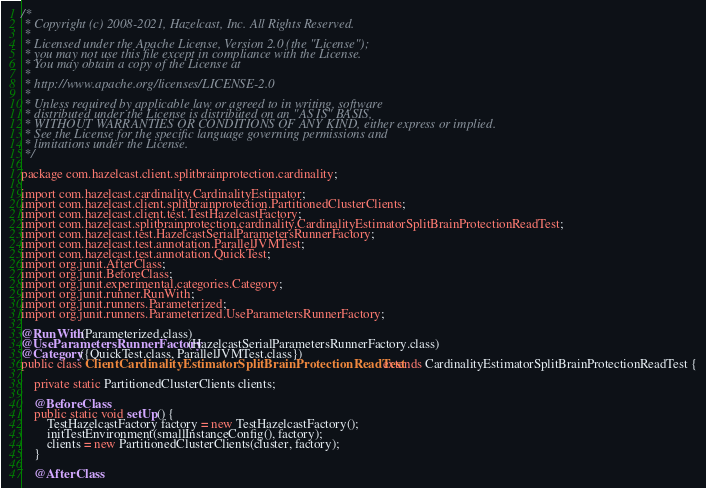<code> <loc_0><loc_0><loc_500><loc_500><_Java_>/*
 * Copyright (c) 2008-2021, Hazelcast, Inc. All Rights Reserved.
 *
 * Licensed under the Apache License, Version 2.0 (the "License");
 * you may not use this file except in compliance with the License.
 * You may obtain a copy of the License at
 *
 * http://www.apache.org/licenses/LICENSE-2.0
 *
 * Unless required by applicable law or agreed to in writing, software
 * distributed under the License is distributed on an "AS IS" BASIS,
 * WITHOUT WARRANTIES OR CONDITIONS OF ANY KIND, either express or implied.
 * See the License for the specific language governing permissions and
 * limitations under the License.
 */

package com.hazelcast.client.splitbrainprotection.cardinality;

import com.hazelcast.cardinality.CardinalityEstimator;
import com.hazelcast.client.splitbrainprotection.PartitionedClusterClients;
import com.hazelcast.client.test.TestHazelcastFactory;
import com.hazelcast.splitbrainprotection.cardinality.CardinalityEstimatorSplitBrainProtectionReadTest;
import com.hazelcast.test.HazelcastSerialParametersRunnerFactory;
import com.hazelcast.test.annotation.ParallelJVMTest;
import com.hazelcast.test.annotation.QuickTest;
import org.junit.AfterClass;
import org.junit.BeforeClass;
import org.junit.experimental.categories.Category;
import org.junit.runner.RunWith;
import org.junit.runners.Parameterized;
import org.junit.runners.Parameterized.UseParametersRunnerFactory;

@RunWith(Parameterized.class)
@UseParametersRunnerFactory(HazelcastSerialParametersRunnerFactory.class)
@Category({QuickTest.class, ParallelJVMTest.class})
public class ClientCardinalityEstimatorSplitBrainProtectionReadTest extends CardinalityEstimatorSplitBrainProtectionReadTest {

    private static PartitionedClusterClients clients;

    @BeforeClass
    public static void setUp() {
        TestHazelcastFactory factory = new TestHazelcastFactory();
        initTestEnvironment(smallInstanceConfig(), factory);
        clients = new PartitionedClusterClients(cluster, factory);
    }

    @AfterClass</code> 